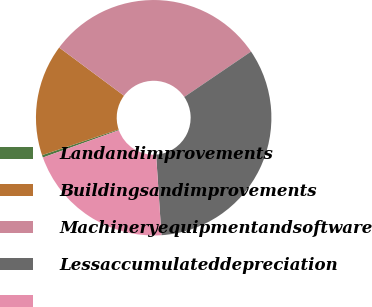Convert chart. <chart><loc_0><loc_0><loc_500><loc_500><pie_chart><fcel>Landandimprovements<fcel>Buildingsandimprovements<fcel>Machineryequipmentandsoftware<fcel>Lessaccumulateddepreciation<fcel>Unnamed: 4<nl><fcel>0.34%<fcel>15.32%<fcel>30.33%<fcel>33.45%<fcel>20.56%<nl></chart> 